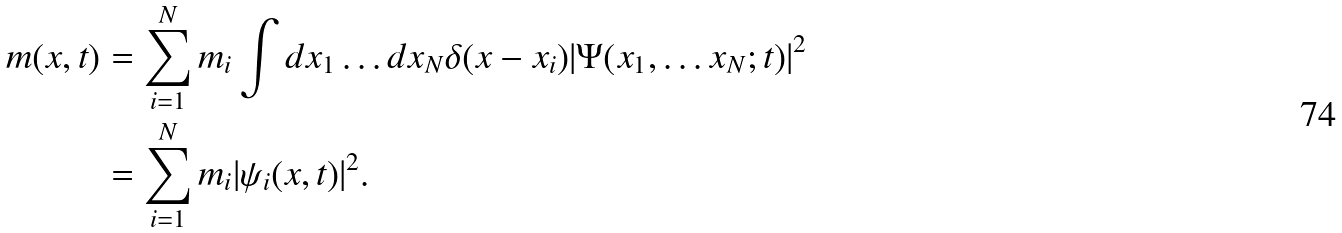<formula> <loc_0><loc_0><loc_500><loc_500>m ( x , t ) & = \sum _ { i = 1 } ^ { N } m _ { i } \int d x _ { 1 } \dots d x _ { N } \delta ( x - x _ { i } ) | \Psi ( x _ { 1 } , \dots x _ { N } ; t ) | ^ { 2 } \\ & = \sum _ { i = 1 } ^ { N } m _ { i } | \psi _ { i } ( x , t ) | ^ { 2 } .</formula> 